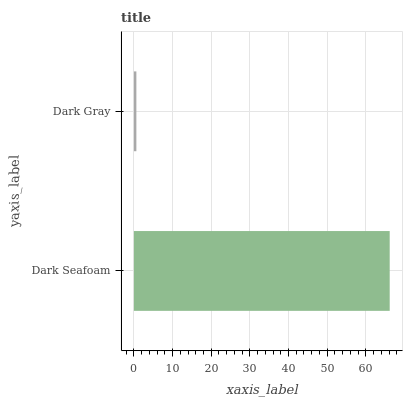Is Dark Gray the minimum?
Answer yes or no. Yes. Is Dark Seafoam the maximum?
Answer yes or no. Yes. Is Dark Gray the maximum?
Answer yes or no. No. Is Dark Seafoam greater than Dark Gray?
Answer yes or no. Yes. Is Dark Gray less than Dark Seafoam?
Answer yes or no. Yes. Is Dark Gray greater than Dark Seafoam?
Answer yes or no. No. Is Dark Seafoam less than Dark Gray?
Answer yes or no. No. Is Dark Seafoam the high median?
Answer yes or no. Yes. Is Dark Gray the low median?
Answer yes or no. Yes. Is Dark Gray the high median?
Answer yes or no. No. Is Dark Seafoam the low median?
Answer yes or no. No. 